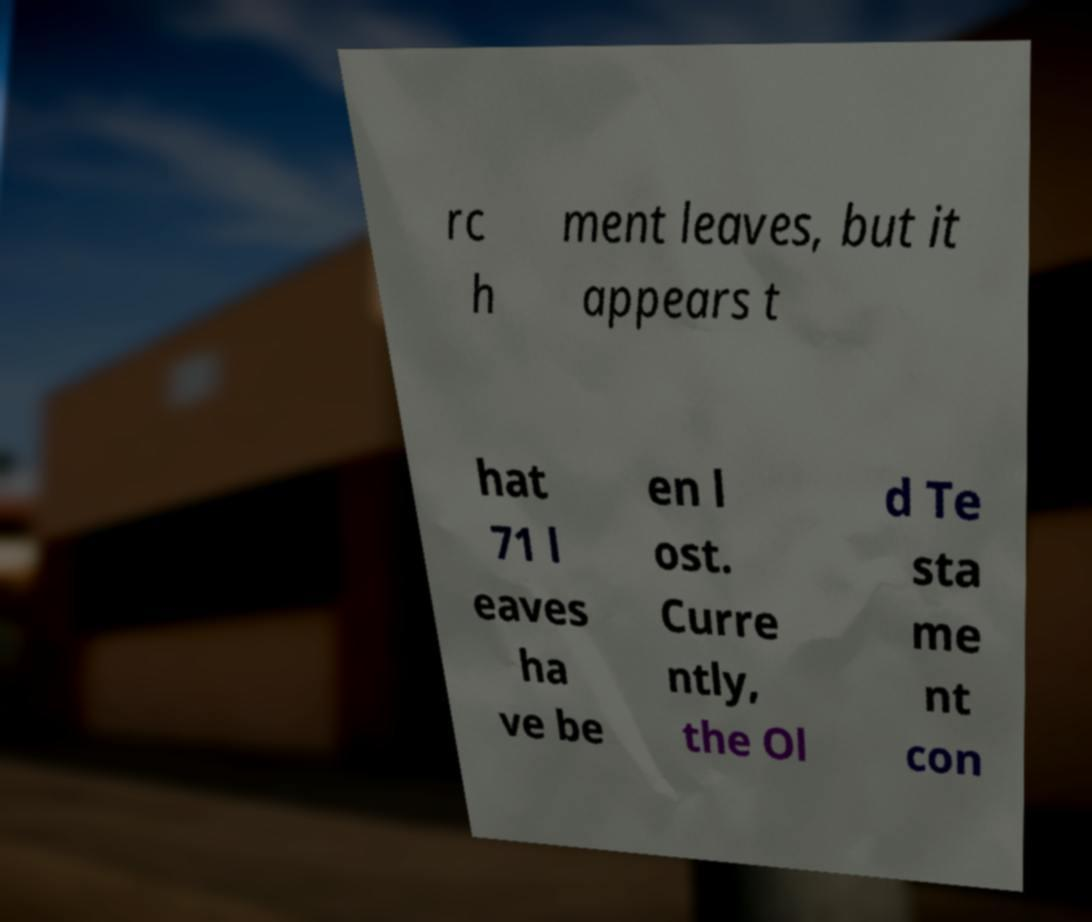Could you assist in decoding the text presented in this image and type it out clearly? rc h ment leaves, but it appears t hat 71 l eaves ha ve be en l ost. Curre ntly, the Ol d Te sta me nt con 